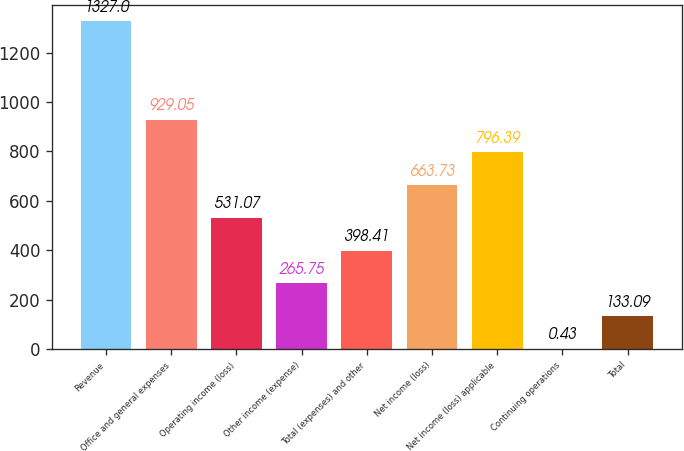Convert chart. <chart><loc_0><loc_0><loc_500><loc_500><bar_chart><fcel>Revenue<fcel>Office and general expenses<fcel>Operating income (loss)<fcel>Other income (expense)<fcel>Total (expenses) and other<fcel>Net income (loss)<fcel>Net income (loss) applicable<fcel>Continuing operations<fcel>Total<nl><fcel>1327<fcel>929.05<fcel>531.07<fcel>265.75<fcel>398.41<fcel>663.73<fcel>796.39<fcel>0.43<fcel>133.09<nl></chart> 